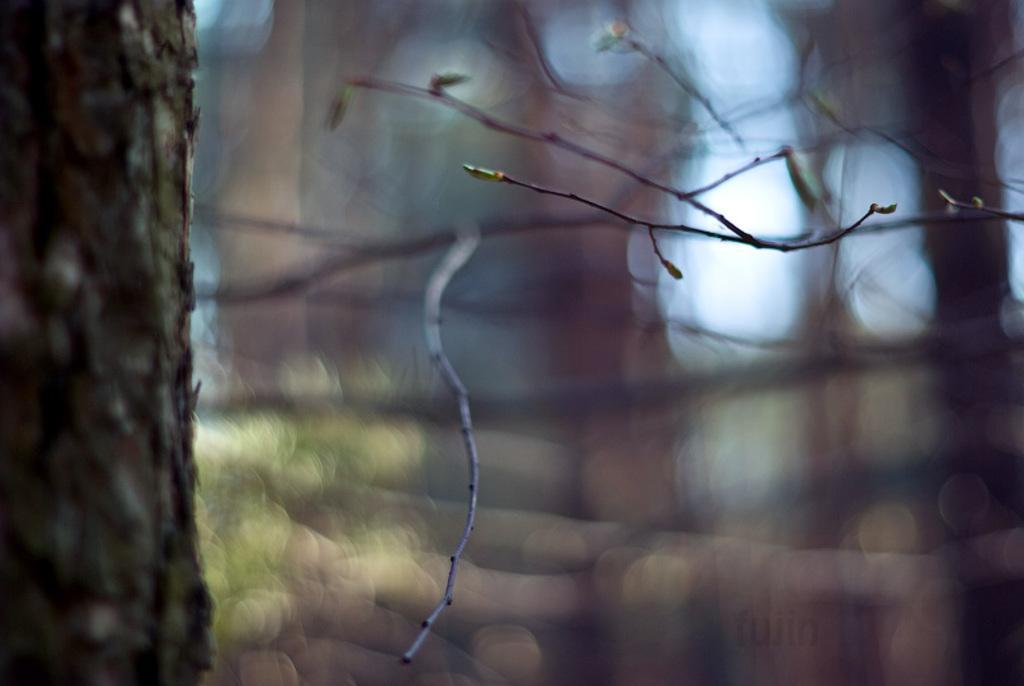In one or two sentences, can you explain what this image depicts? In front of the image there is a tree and the background of the image is blur. There is some text at the bottom of the image. 